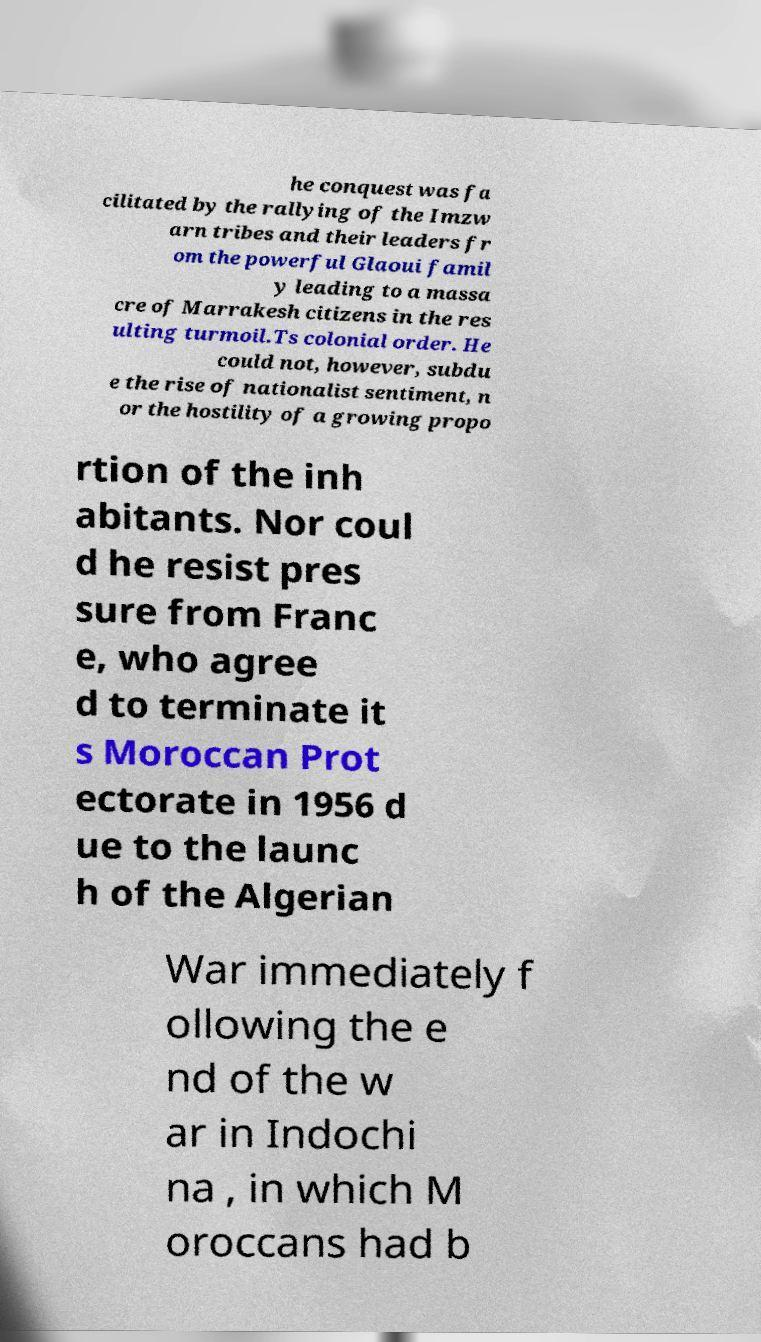What messages or text are displayed in this image? I need them in a readable, typed format. he conquest was fa cilitated by the rallying of the Imzw arn tribes and their leaders fr om the powerful Glaoui famil y leading to a massa cre of Marrakesh citizens in the res ulting turmoil.Ts colonial order. He could not, however, subdu e the rise of nationalist sentiment, n or the hostility of a growing propo rtion of the inh abitants. Nor coul d he resist pres sure from Franc e, who agree d to terminate it s Moroccan Prot ectorate in 1956 d ue to the launc h of the Algerian War immediately f ollowing the e nd of the w ar in Indochi na , in which M oroccans had b 